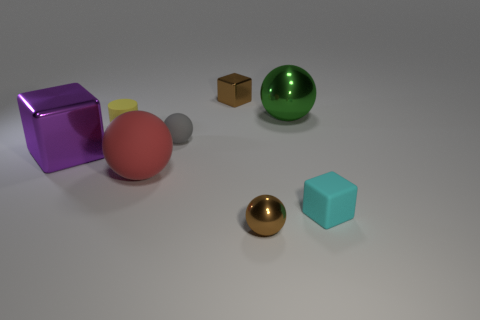Subtract all tiny brown cubes. How many cubes are left? 2 Add 8 brown metallic spheres. How many brown metallic spheres are left? 9 Add 2 small yellow rubber objects. How many small yellow rubber objects exist? 3 Add 2 yellow cylinders. How many objects exist? 10 Subtract all brown blocks. How many blocks are left? 2 Subtract 0 red blocks. How many objects are left? 8 Subtract all cylinders. How many objects are left? 7 Subtract 1 cylinders. How many cylinders are left? 0 Subtract all yellow spheres. Subtract all gray cubes. How many spheres are left? 4 Subtract all blue cylinders. How many brown balls are left? 1 